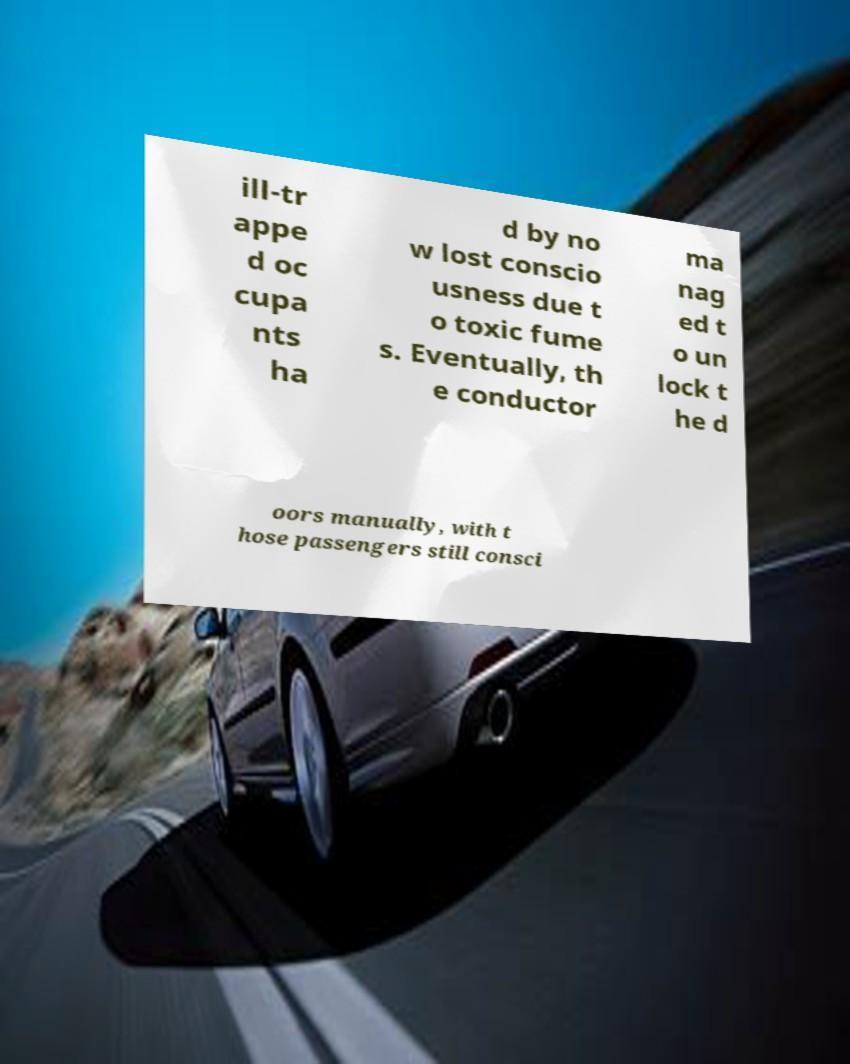Can you read and provide the text displayed in the image?This photo seems to have some interesting text. Can you extract and type it out for me? ill-tr appe d oc cupa nts ha d by no w lost conscio usness due t o toxic fume s. Eventually, th e conductor ma nag ed t o un lock t he d oors manually, with t hose passengers still consci 